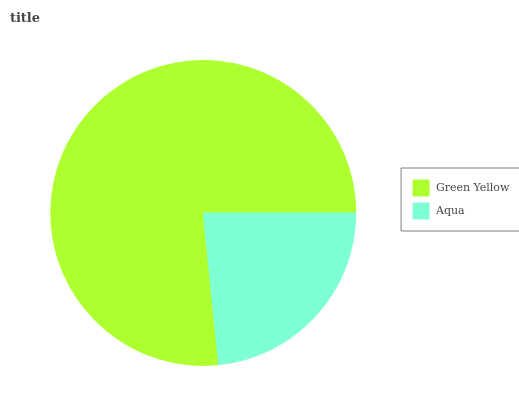Is Aqua the minimum?
Answer yes or no. Yes. Is Green Yellow the maximum?
Answer yes or no. Yes. Is Aqua the maximum?
Answer yes or no. No. Is Green Yellow greater than Aqua?
Answer yes or no. Yes. Is Aqua less than Green Yellow?
Answer yes or no. Yes. Is Aqua greater than Green Yellow?
Answer yes or no. No. Is Green Yellow less than Aqua?
Answer yes or no. No. Is Green Yellow the high median?
Answer yes or no. Yes. Is Aqua the low median?
Answer yes or no. Yes. Is Aqua the high median?
Answer yes or no. No. Is Green Yellow the low median?
Answer yes or no. No. 